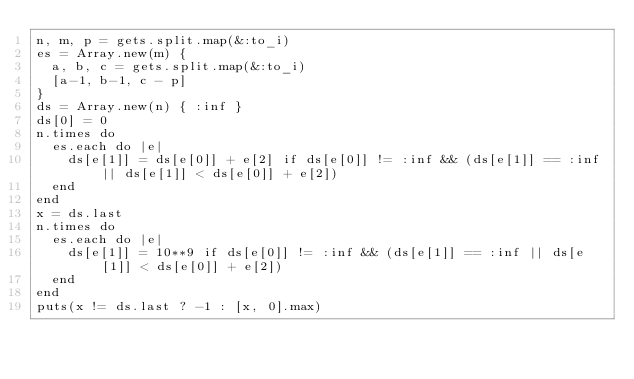<code> <loc_0><loc_0><loc_500><loc_500><_Ruby_>n, m, p = gets.split.map(&:to_i)
es = Array.new(m) {
  a, b, c = gets.split.map(&:to_i)
  [a-1, b-1, c - p]
}
ds = Array.new(n) { :inf }
ds[0] = 0
n.times do
  es.each do |e|
    ds[e[1]] = ds[e[0]] + e[2] if ds[e[0]] != :inf && (ds[e[1]] == :inf || ds[e[1]] < ds[e[0]] + e[2])
  end
end
x = ds.last
n.times do
  es.each do |e|
    ds[e[1]] = 10**9 if ds[e[0]] != :inf && (ds[e[1]] == :inf || ds[e[1]] < ds[e[0]] + e[2])
  end
end
puts(x != ds.last ? -1 : [x, 0].max)</code> 